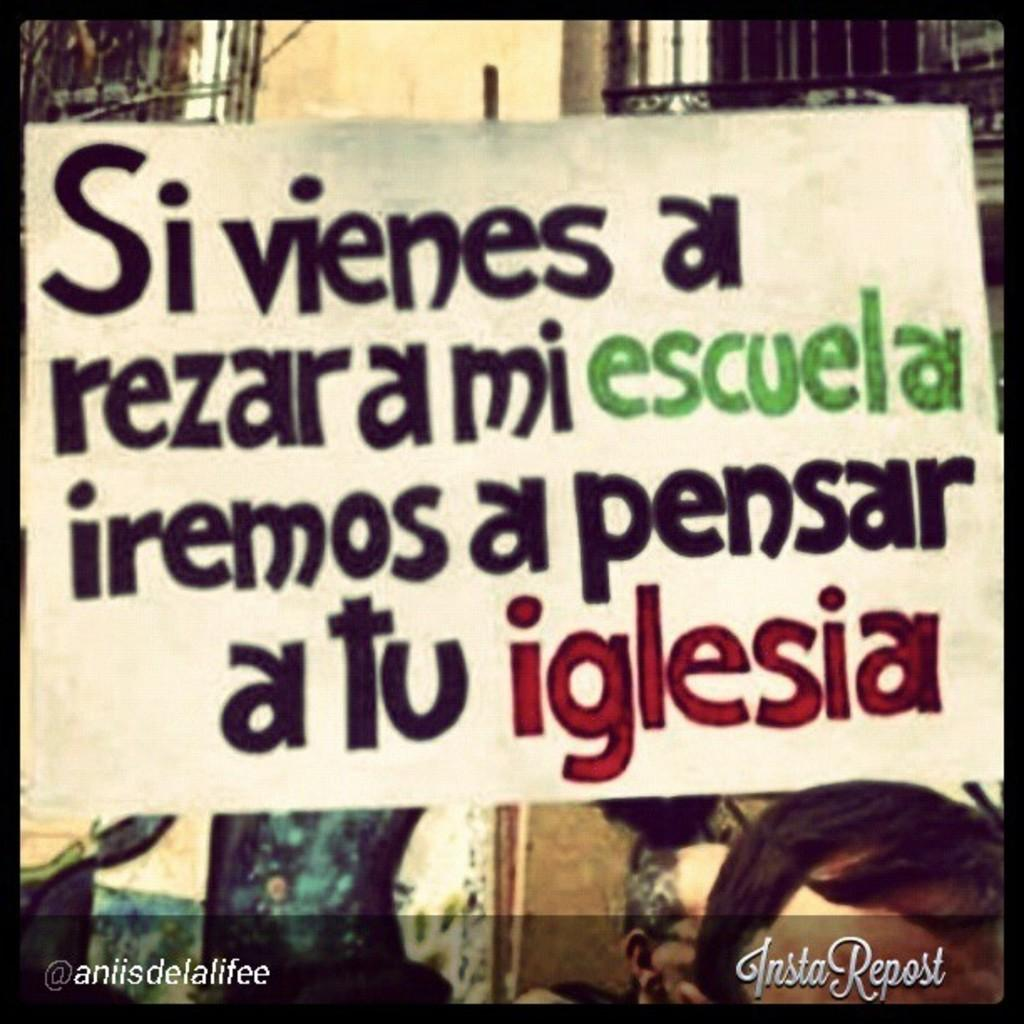What is present in the image that is used for displaying information or messages? There is a banner in the image. What can be found on the banner? The banner has some text on it. What type of glue is used to attach the banner to the canvas in the image? There is no canvas or glue present in the image; it only features a banner with text. Can you see any birds perched on the banner in the image? There are no birds present in the image. 